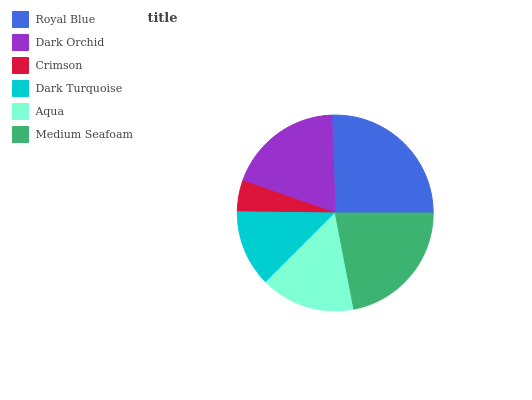Is Crimson the minimum?
Answer yes or no. Yes. Is Royal Blue the maximum?
Answer yes or no. Yes. Is Dark Orchid the minimum?
Answer yes or no. No. Is Dark Orchid the maximum?
Answer yes or no. No. Is Royal Blue greater than Dark Orchid?
Answer yes or no. Yes. Is Dark Orchid less than Royal Blue?
Answer yes or no. Yes. Is Dark Orchid greater than Royal Blue?
Answer yes or no. No. Is Royal Blue less than Dark Orchid?
Answer yes or no. No. Is Dark Orchid the high median?
Answer yes or no. Yes. Is Aqua the low median?
Answer yes or no. Yes. Is Crimson the high median?
Answer yes or no. No. Is Royal Blue the low median?
Answer yes or no. No. 